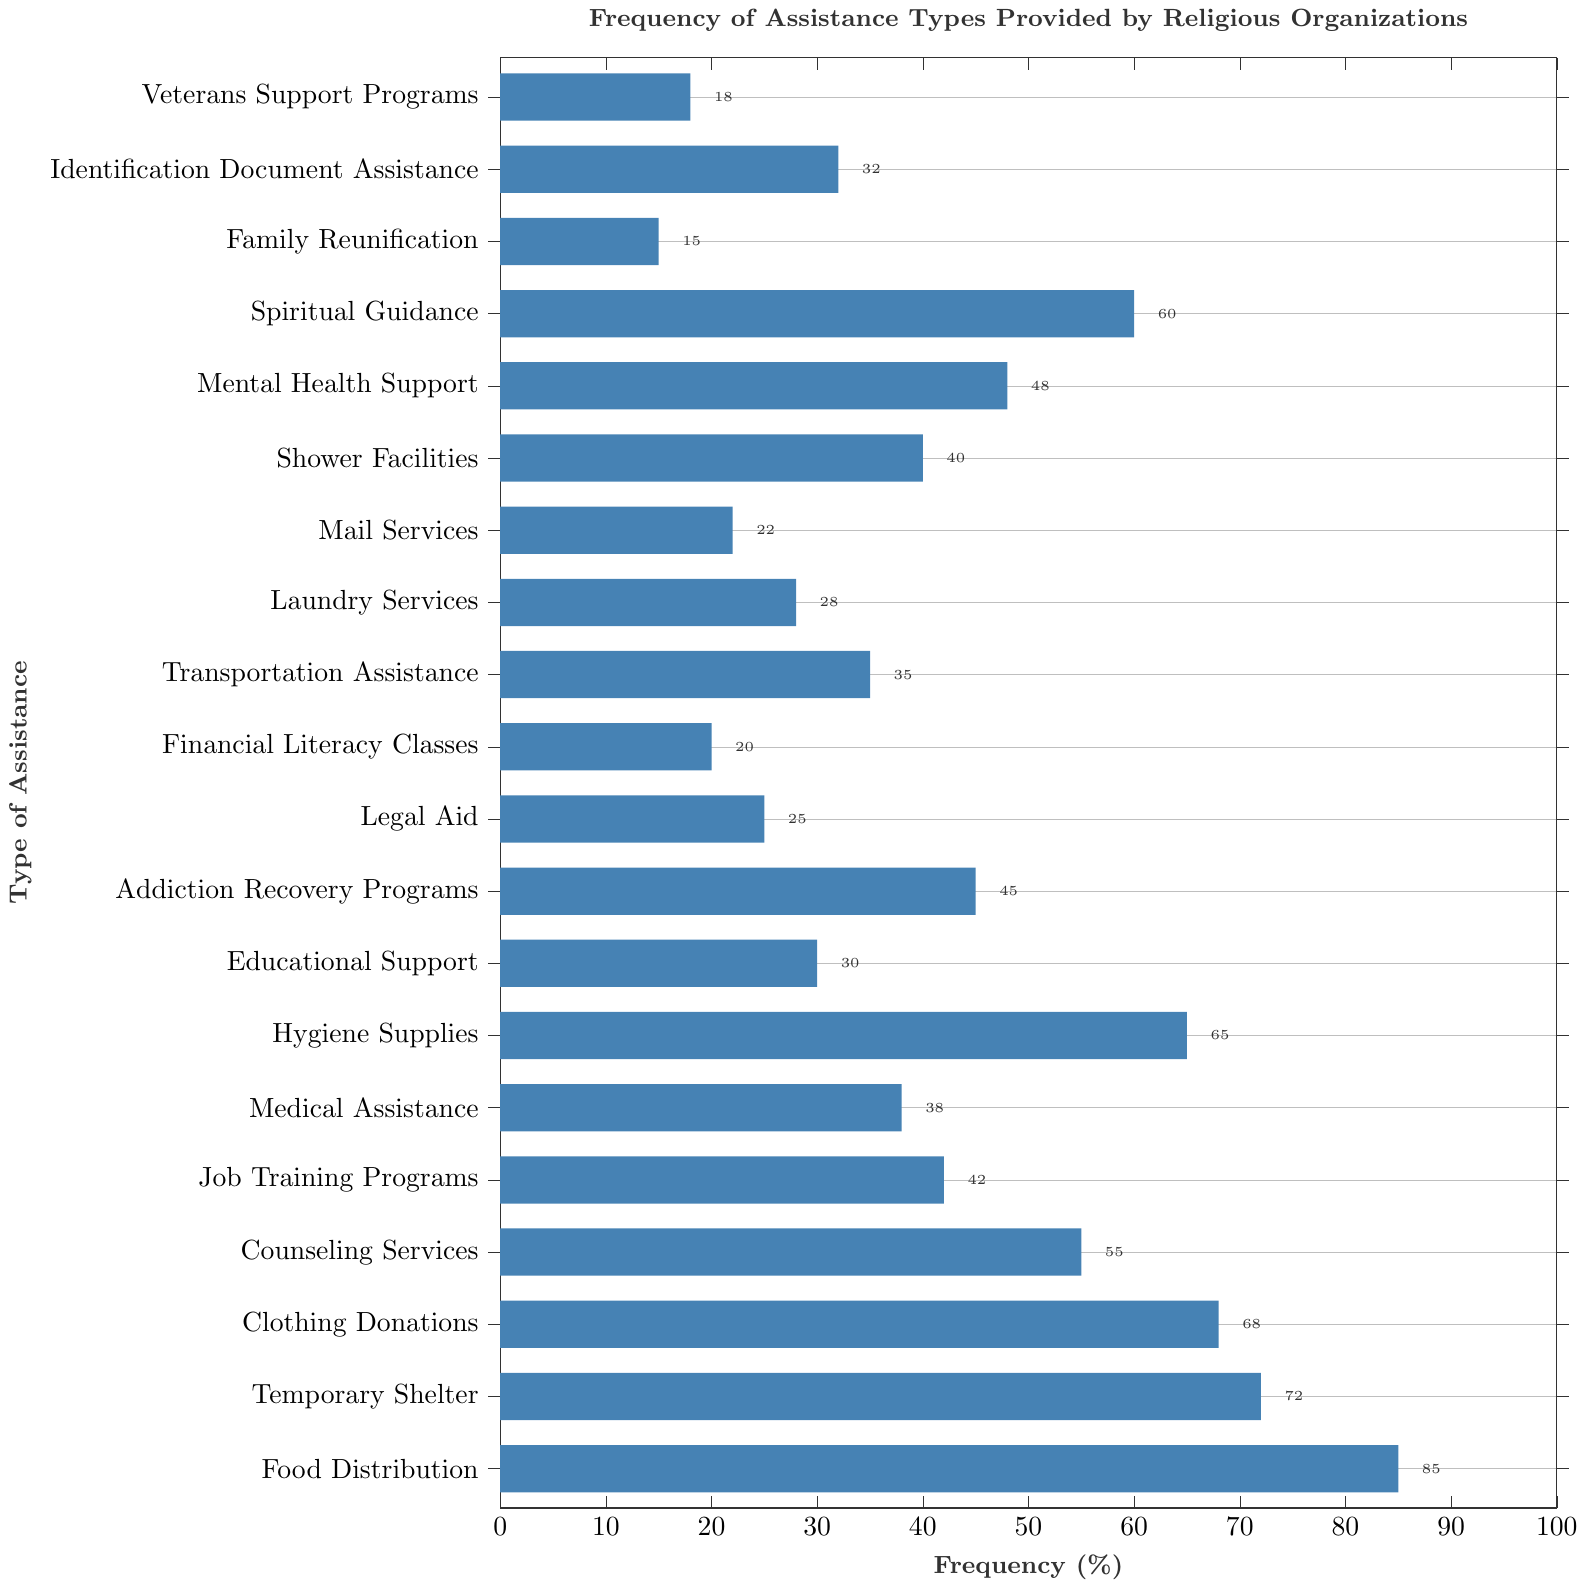Which type of assistance is provided most frequently? The type of assistance that is provided most frequently can be identified as the bar that extends the furthest to the right. In this figure, "Food Distribution" has the highest frequency at 85%.
Answer: Food Distribution Which services are provided by religious organizations at a frequency of over 70%? Services with a frequency over 70% can be identified by finding the bars whose lengths exceed the 70% mark on the x-axis. These services are "Food Distribution" (85%) and "Temporary Shelter" (72%).
Answer: Food Distribution, Temporary Shelter How much more frequent is Counseling Services compared to Legal Aid? To find how much more frequent "Counseling Services" is compared to "Legal Aid", subtract the frequency of Legal Aid (25%) from the frequency of Counseling Services (55%). The difference is 55% - 25% = 30%.
Answer: 30% What is the median frequency of the listed assistance types? To find the median frequency, list all the frequencies in ascending order and find the middle value. The sorted frequencies are: 15, 18, 20, 22, 25, 28, 30, 32, 35, 38, 40, 42, 45, 48, 55, 60, 65, 68, 72, 85. The middle values are the 10th and 11th: (38 + 40) / 2 = 39%.
Answer: 39% Which type of assistance is provided exactly 45% of the time? The type of assistance with a frequency of 45% can be found by examining the bars and their labels. "Addiction Recovery Programs" is provided at exactly 45%.
Answer: Addiction Recovery Programs Among Medical Assistance, Job Training Programs, and Educational Support, which has the lowest frequency? Compare the frequencies of the three services. Medical Assistance is 38%, Job Training Programs is 42%, and Educational Support is 30%. The lowest frequency is Educational Support at 30%.
Answer: Educational Support Is the frequency of Laundry Services higher or lower than Mental Health Support? By comparing the lengths of the bars for Laundry Services and Mental Health Support, we see that Laundry Services has a frequency of 28% while Mental Health Support has a frequency of 48%. Thus, Laundry Services is lower.
Answer: Lower What is the combined frequency of Temporary Shelter and Shower Facilities? Add the frequencies of Temporary Shelter (72%) and Shower Facilities (40%). 72% + 40% = 112%.
Answer: 112% If Identification Document Assistance increased by 10%, what would its new frequency be? Identification Document Assistance currently has a frequency of 32%. If it increases by 10%, the new frequency would be 32% + 10% = 42%.
Answer: 42% What is the visual difference between the bars for Veterans Support Programs and Spiritual Guidance? Visually, "Veterans Support Programs" has a much shorter bar (18%) compared to "Spiritual Guidance" (60%), indicating that the latter is provided significantly more frequently.
Answer: The bar for Spiritual Guidance is much longer 